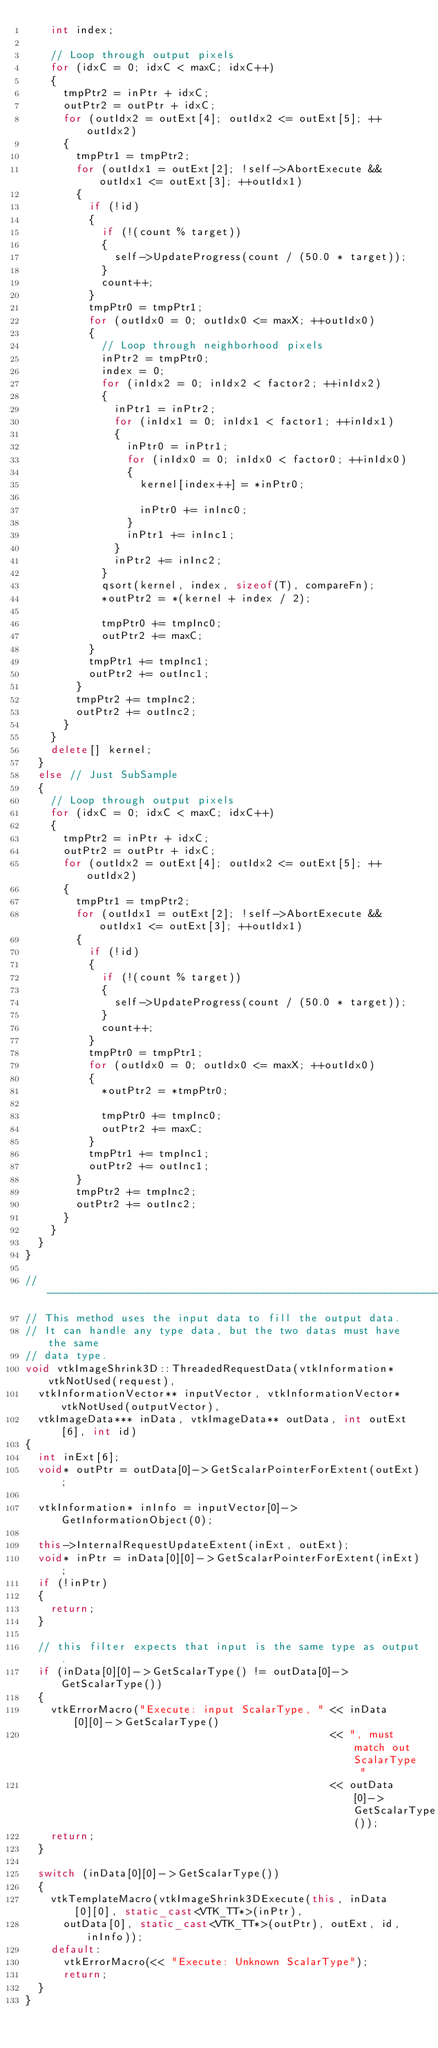Convert code to text. <code><loc_0><loc_0><loc_500><loc_500><_C++_>    int index;

    // Loop through output pixels
    for (idxC = 0; idxC < maxC; idxC++)
    {
      tmpPtr2 = inPtr + idxC;
      outPtr2 = outPtr + idxC;
      for (outIdx2 = outExt[4]; outIdx2 <= outExt[5]; ++outIdx2)
      {
        tmpPtr1 = tmpPtr2;
        for (outIdx1 = outExt[2]; !self->AbortExecute && outIdx1 <= outExt[3]; ++outIdx1)
        {
          if (!id)
          {
            if (!(count % target))
            {
              self->UpdateProgress(count / (50.0 * target));
            }
            count++;
          }
          tmpPtr0 = tmpPtr1;
          for (outIdx0 = 0; outIdx0 <= maxX; ++outIdx0)
          {
            // Loop through neighborhood pixels
            inPtr2 = tmpPtr0;
            index = 0;
            for (inIdx2 = 0; inIdx2 < factor2; ++inIdx2)
            {
              inPtr1 = inPtr2;
              for (inIdx1 = 0; inIdx1 < factor1; ++inIdx1)
              {
                inPtr0 = inPtr1;
                for (inIdx0 = 0; inIdx0 < factor0; ++inIdx0)
                {
                  kernel[index++] = *inPtr0;

                  inPtr0 += inInc0;
                }
                inPtr1 += inInc1;
              }
              inPtr2 += inInc2;
            }
            qsort(kernel, index, sizeof(T), compareFn);
            *outPtr2 = *(kernel + index / 2);

            tmpPtr0 += tmpInc0;
            outPtr2 += maxC;
          }
          tmpPtr1 += tmpInc1;
          outPtr2 += outInc1;
        }
        tmpPtr2 += tmpInc2;
        outPtr2 += outInc2;
      }
    }
    delete[] kernel;
  }
  else // Just SubSample
  {
    // Loop through output pixels
    for (idxC = 0; idxC < maxC; idxC++)
    {
      tmpPtr2 = inPtr + idxC;
      outPtr2 = outPtr + idxC;
      for (outIdx2 = outExt[4]; outIdx2 <= outExt[5]; ++outIdx2)
      {
        tmpPtr1 = tmpPtr2;
        for (outIdx1 = outExt[2]; !self->AbortExecute && outIdx1 <= outExt[3]; ++outIdx1)
        {
          if (!id)
          {
            if (!(count % target))
            {
              self->UpdateProgress(count / (50.0 * target));
            }
            count++;
          }
          tmpPtr0 = tmpPtr1;
          for (outIdx0 = 0; outIdx0 <= maxX; ++outIdx0)
          {
            *outPtr2 = *tmpPtr0;

            tmpPtr0 += tmpInc0;
            outPtr2 += maxC;
          }
          tmpPtr1 += tmpInc1;
          outPtr2 += outInc1;
        }
        tmpPtr2 += tmpInc2;
        outPtr2 += outInc2;
      }
    }
  }
}

//------------------------------------------------------------------------------
// This method uses the input data to fill the output data.
// It can handle any type data, but the two datas must have the same
// data type.
void vtkImageShrink3D::ThreadedRequestData(vtkInformation* vtkNotUsed(request),
  vtkInformationVector** inputVector, vtkInformationVector* vtkNotUsed(outputVector),
  vtkImageData*** inData, vtkImageData** outData, int outExt[6], int id)
{
  int inExt[6];
  void* outPtr = outData[0]->GetScalarPointerForExtent(outExt);

  vtkInformation* inInfo = inputVector[0]->GetInformationObject(0);

  this->InternalRequestUpdateExtent(inExt, outExt);
  void* inPtr = inData[0][0]->GetScalarPointerForExtent(inExt);
  if (!inPtr)
  {
    return;
  }

  // this filter expects that input is the same type as output.
  if (inData[0][0]->GetScalarType() != outData[0]->GetScalarType())
  {
    vtkErrorMacro("Execute: input ScalarType, " << inData[0][0]->GetScalarType()
                                                << ", must match out ScalarType "
                                                << outData[0]->GetScalarType());
    return;
  }

  switch (inData[0][0]->GetScalarType())
  {
    vtkTemplateMacro(vtkImageShrink3DExecute(this, inData[0][0], static_cast<VTK_TT*>(inPtr),
      outData[0], static_cast<VTK_TT*>(outPtr), outExt, id, inInfo));
    default:
      vtkErrorMacro(<< "Execute: Unknown ScalarType");
      return;
  }
}
</code> 